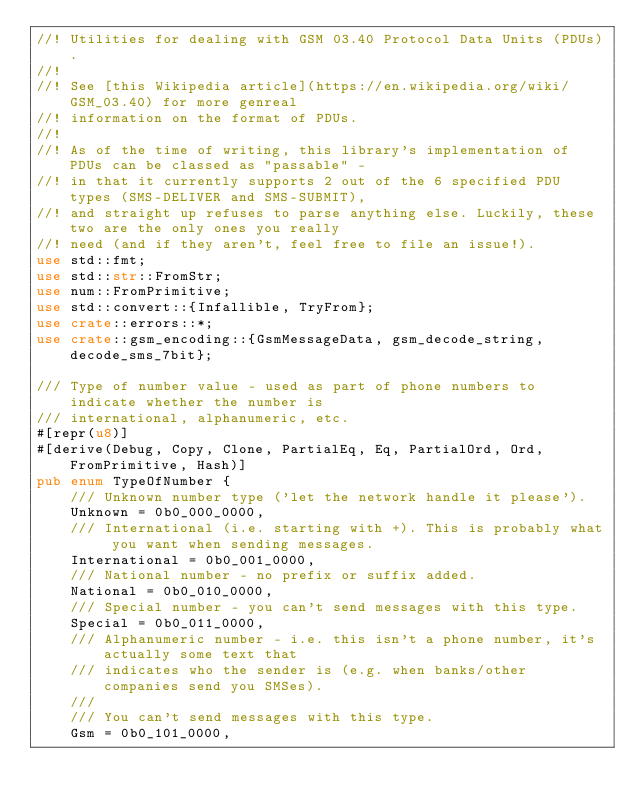Convert code to text. <code><loc_0><loc_0><loc_500><loc_500><_Rust_>//! Utilities for dealing with GSM 03.40 Protocol Data Units (PDUs).
//!
//! See [this Wikipedia article](https://en.wikipedia.org/wiki/GSM_03.40) for more genreal
//! information on the format of PDUs.
//!
//! As of the time of writing, this library's implementation of PDUs can be classed as "passable" -
//! in that it currently supports 2 out of the 6 specified PDU types (SMS-DELIVER and SMS-SUBMIT),
//! and straight up refuses to parse anything else. Luckily, these two are the only ones you really
//! need (and if they aren't, feel free to file an issue!).
use std::fmt;
use std::str::FromStr;
use num::FromPrimitive;
use std::convert::{Infallible, TryFrom};
use crate::errors::*;
use crate::gsm_encoding::{GsmMessageData, gsm_decode_string, decode_sms_7bit};

/// Type of number value - used as part of phone numbers to indicate whether the number is
/// international, alphanumeric, etc.
#[repr(u8)]
#[derive(Debug, Copy, Clone, PartialEq, Eq, PartialOrd, Ord, FromPrimitive, Hash)]
pub enum TypeOfNumber {
    /// Unknown number type ('let the network handle it please').
    Unknown = 0b0_000_0000,
    /// International (i.e. starting with +). This is probably what you want when sending messages.
    International = 0b0_001_0000,
    /// National number - no prefix or suffix added.
    National = 0b0_010_0000,
    /// Special number - you can't send messages with this type.
    Special = 0b0_011_0000,
    /// Alphanumeric number - i.e. this isn't a phone number, it's actually some text that
    /// indicates who the sender is (e.g. when banks/other companies send you SMSes).
    ///
    /// You can't send messages with this type.
    Gsm = 0b0_101_0000,</code> 